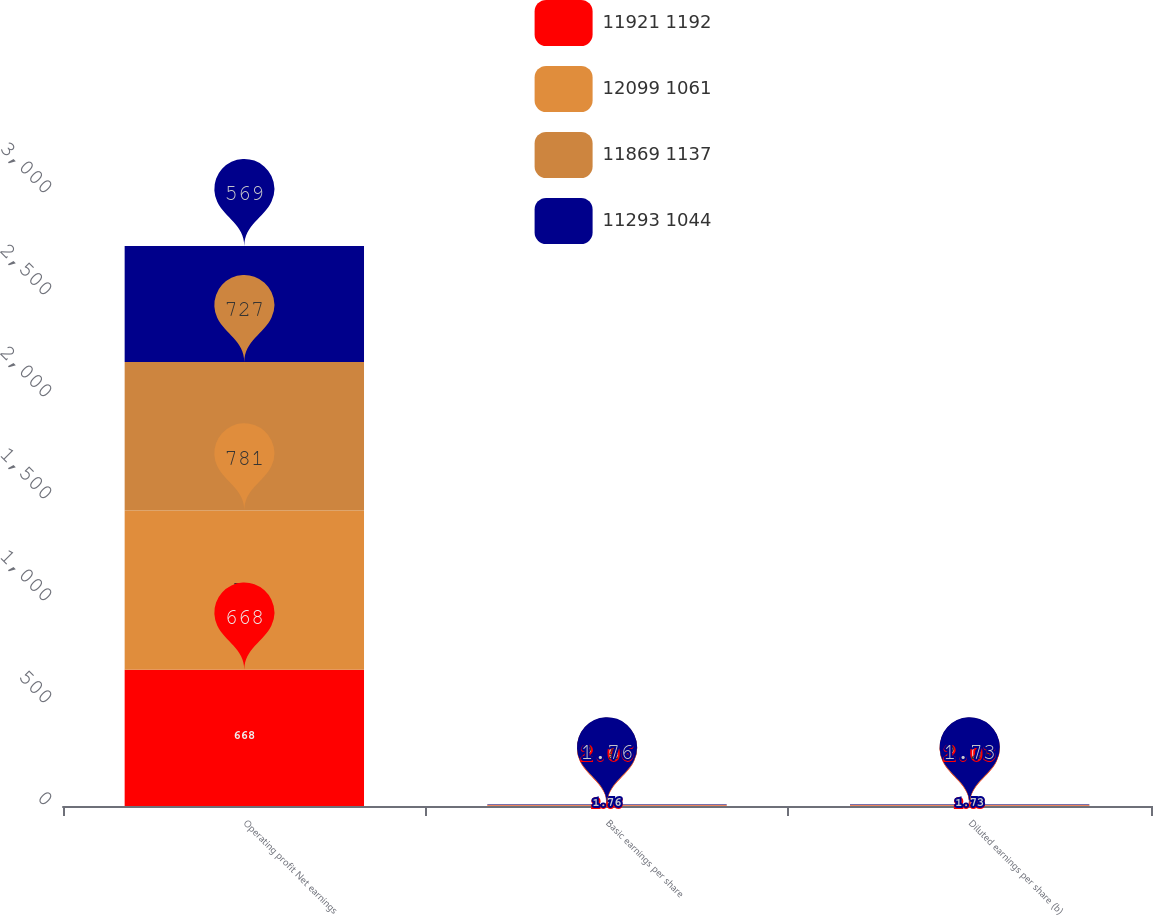<chart> <loc_0><loc_0><loc_500><loc_500><stacked_bar_chart><ecel><fcel>Operating profit Net earnings<fcel>Basic earnings per share<fcel>Diluted earnings per share (b)<nl><fcel>11921 1192<fcel>668<fcel>2.06<fcel>2.03<nl><fcel>12099 1061<fcel>781<fcel>2.41<fcel>2.38<nl><fcel>11869 1137<fcel>727<fcel>2.25<fcel>2.21<nl><fcel>11293 1044<fcel>569<fcel>1.76<fcel>1.73<nl></chart> 